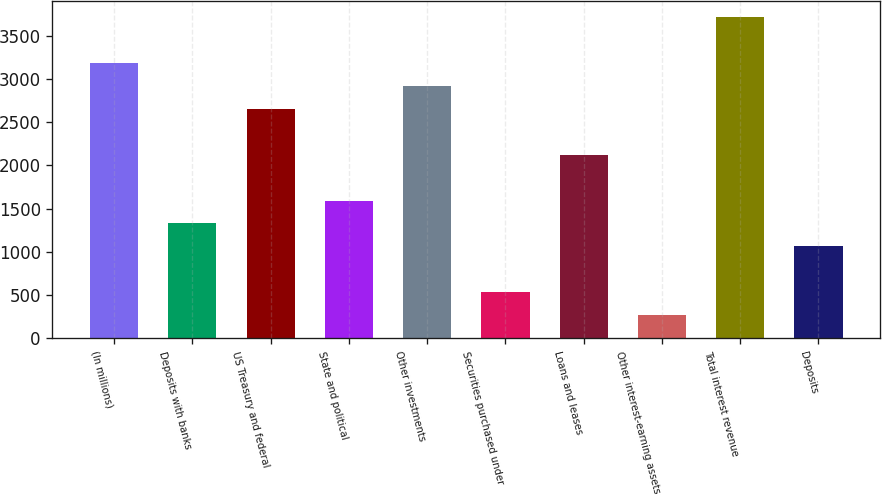Convert chart to OTSL. <chart><loc_0><loc_0><loc_500><loc_500><bar_chart><fcel>(In millions)<fcel>Deposits with banks<fcel>US Treasury and federal<fcel>State and political<fcel>Other investments<fcel>Securities purchased under<fcel>Loans and leases<fcel>Other interest-earning assets<fcel>Total interest revenue<fcel>Deposits<nl><fcel>3181.4<fcel>1328.5<fcel>2652<fcel>1593.2<fcel>2916.7<fcel>534.4<fcel>2122.6<fcel>269.7<fcel>3710.8<fcel>1063.8<nl></chart> 